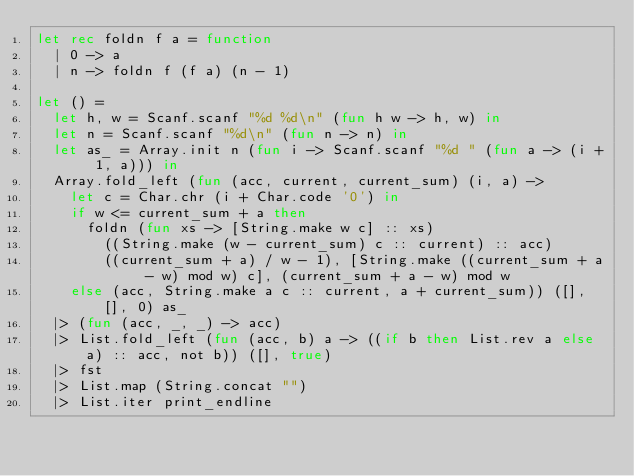Convert code to text. <code><loc_0><loc_0><loc_500><loc_500><_OCaml_>let rec foldn f a = function
  | 0 -> a
  | n -> foldn f (f a) (n - 1)

let () =
  let h, w = Scanf.scanf "%d %d\n" (fun h w -> h, w) in
  let n = Scanf.scanf "%d\n" (fun n -> n) in
  let as_ = Array.init n (fun i -> Scanf.scanf "%d " (fun a -> (i + 1, a))) in
  Array.fold_left (fun (acc, current, current_sum) (i, a) ->
    let c = Char.chr (i + Char.code '0') in
    if w <= current_sum + a then
      foldn (fun xs -> [String.make w c] :: xs)
        ((String.make (w - current_sum) c :: current) :: acc)
        ((current_sum + a) / w - 1), [String.make ((current_sum + a - w) mod w) c], (current_sum + a - w) mod w
    else (acc, String.make a c :: current, a + current_sum)) ([], [], 0) as_
  |> (fun (acc, _, _) -> acc)
  |> List.fold_left (fun (acc, b) a -> ((if b then List.rev a else a) :: acc, not b)) ([], true)
  |> fst
  |> List.map (String.concat "")
  |> List.iter print_endline</code> 